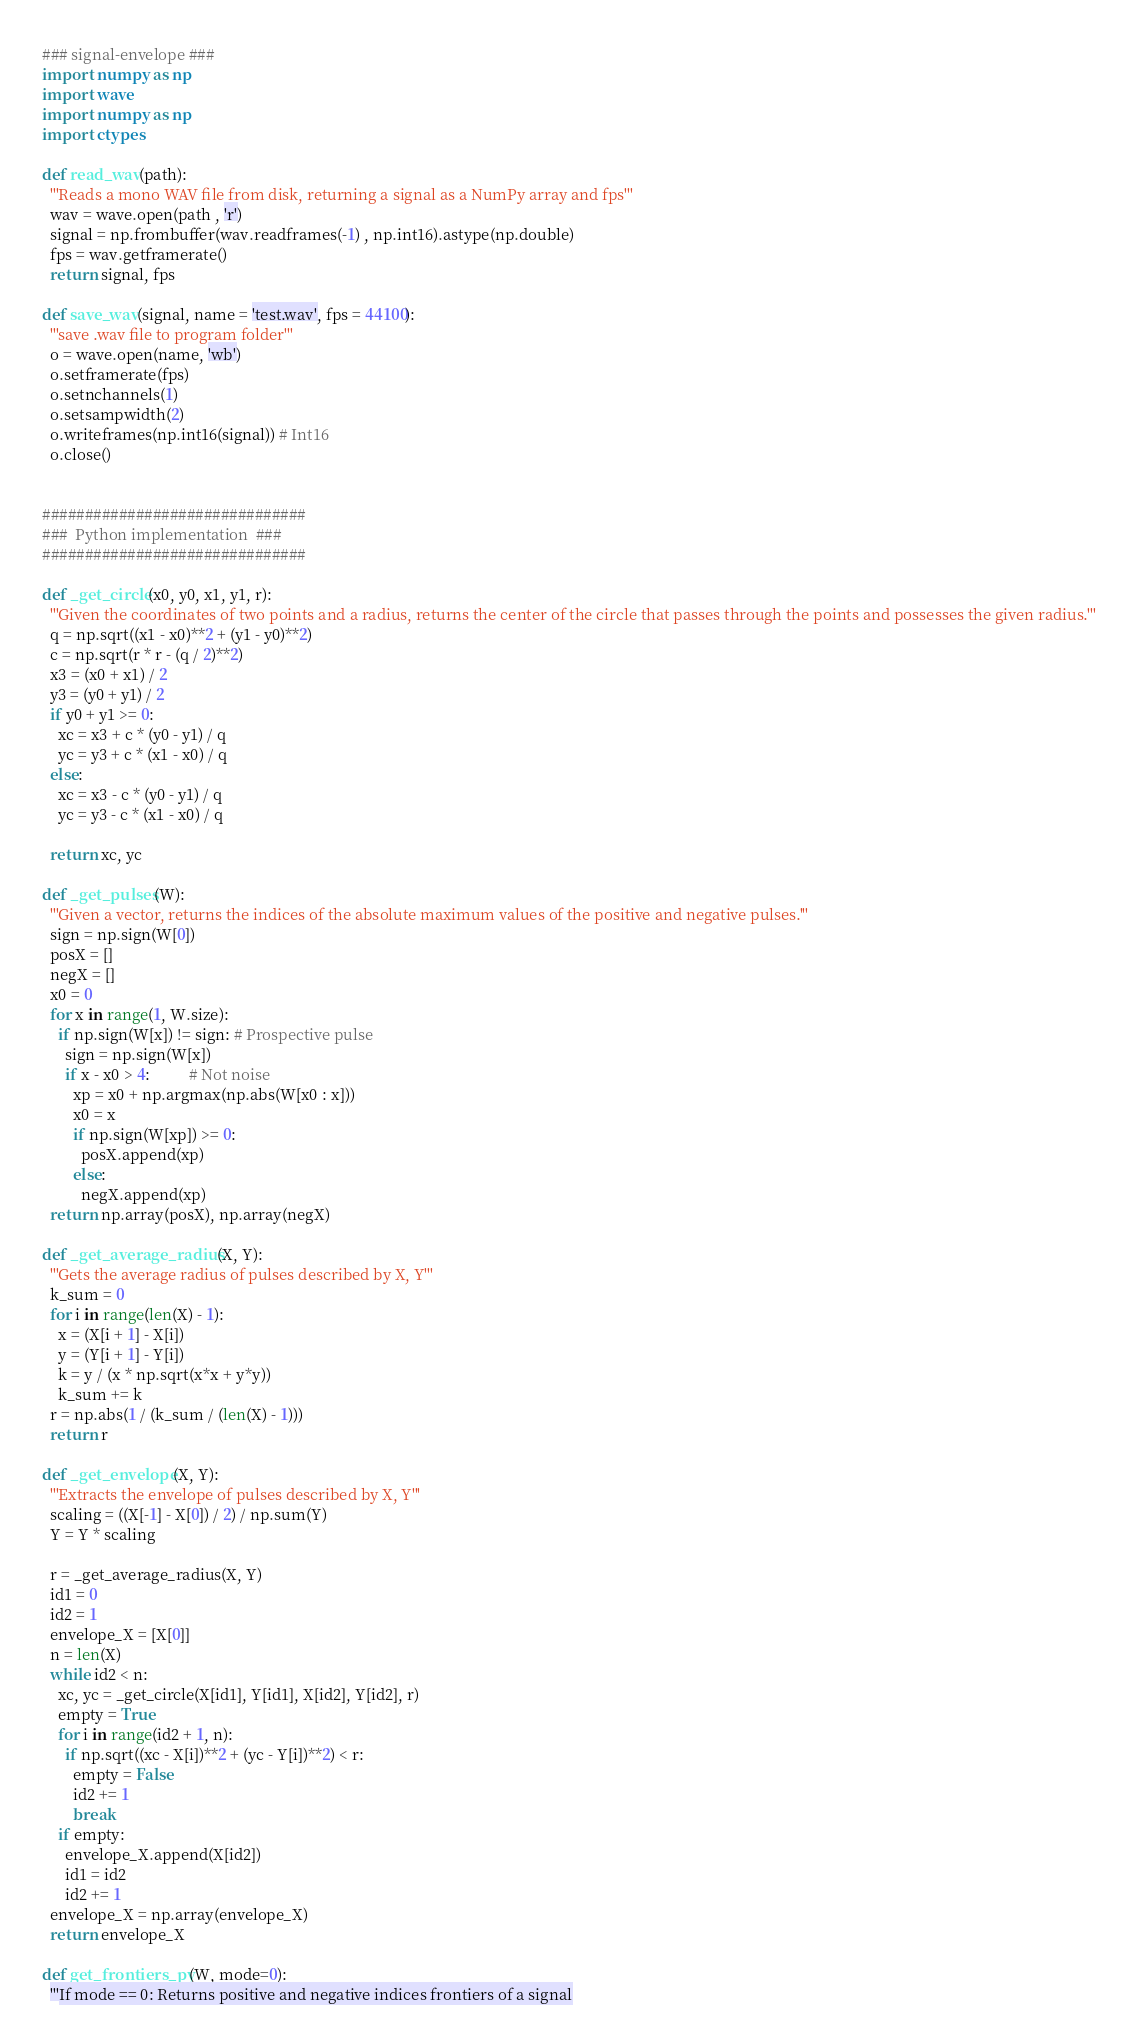Convert code to text. <code><loc_0><loc_0><loc_500><loc_500><_Python_>### signal-envelope ###
import numpy as np
import wave
import numpy as np
import ctypes

def read_wav(path):
  '''Reads a mono WAV file from disk, returning a signal as a NumPy array and fps'''
  wav = wave.open(path , 'r')
  signal = np.frombuffer(wav.readframes(-1) , np.int16).astype(np.double)
  fps = wav.getframerate()
  return signal, fps

def save_wav(signal, name = 'test.wav', fps = 44100): 
  '''save .wav file to program folder'''
  o = wave.open(name, 'wb')
  o.setframerate(fps)
  o.setnchannels(1)
  o.setsampwidth(2)
  o.writeframes(np.int16(signal)) # Int16
  o.close()


###############################
###  Python implementation  ###
###############################

def _get_circle(x0, y0, x1, y1, r):
  '''Given the coordinates of two points and a radius, returns the center of the circle that passes through the points and possesses the given radius.'''
  q = np.sqrt((x1 - x0)**2 + (y1 - y0)**2)
  c = np.sqrt(r * r - (q / 2)**2)
  x3 = (x0 + x1) / 2
  y3 = (y0 + y1) / 2 
  if y0 + y1 >= 0:
    xc = x3 + c * (y0 - y1) / q
    yc = y3 + c * (x1 - x0) / q
  else:
    xc = x3 - c * (y0 - y1) / q
    yc = y3 - c * (x1 - x0) / q

  return xc, yc

def _get_pulses(W):
  '''Given a vector, returns the indices of the absolute maximum values of the positive and negative pulses.'''
  sign = np.sign(W[0])
  posX = []
  negX = []
  x0 = 0
  for x in range(1, W.size):
    if np.sign(W[x]) != sign: # Prospective pulse
      sign = np.sign(W[x])
      if x - x0 > 4:          # Not noise        
        xp = x0 + np.argmax(np.abs(W[x0 : x]))
        x0 = x
        if np.sign(W[xp]) >= 0:
          posX.append(xp)
        else:
          negX.append(xp)
  return np.array(posX), np.array(negX)

def _get_average_radius(X, Y):
  '''Gets the average radius of pulses described by X, Y'''
  k_sum = 0
  for i in range(len(X) - 1):
    x = (X[i + 1] - X[i])
    y = (Y[i + 1] - Y[i])
    k = y / (x * np.sqrt(x*x + y*y))
    k_sum += k
  r = np.abs(1 / (k_sum / (len(X) - 1)))
  return r

def _get_envelope(X, Y):
  '''Extracts the envelope of pulses described by X, Y'''
  scaling = ((X[-1] - X[0]) / 2) / np.sum(Y)
  Y = Y * scaling
  
  r = _get_average_radius(X, Y)
  id1 = 0
  id2 = 1
  envelope_X = [X[0]]
  n = len(X)
  while id2 < n:
    xc, yc = _get_circle(X[id1], Y[id1], X[id2], Y[id2], r)
    empty = True
    for i in range(id2 + 1, n):
      if np.sqrt((xc - X[i])**2 + (yc - Y[i])**2) < r:
        empty = False
        id2 += 1
        break
    if empty:
      envelope_X.append(X[id2])
      id1 = id2
      id2 += 1
  envelope_X = np.array(envelope_X)
  return envelope_X

def get_frontiers_py(W, mode=0):
  '''If mode == 0: Returns positive and negative indices frontiers of a signal</code> 